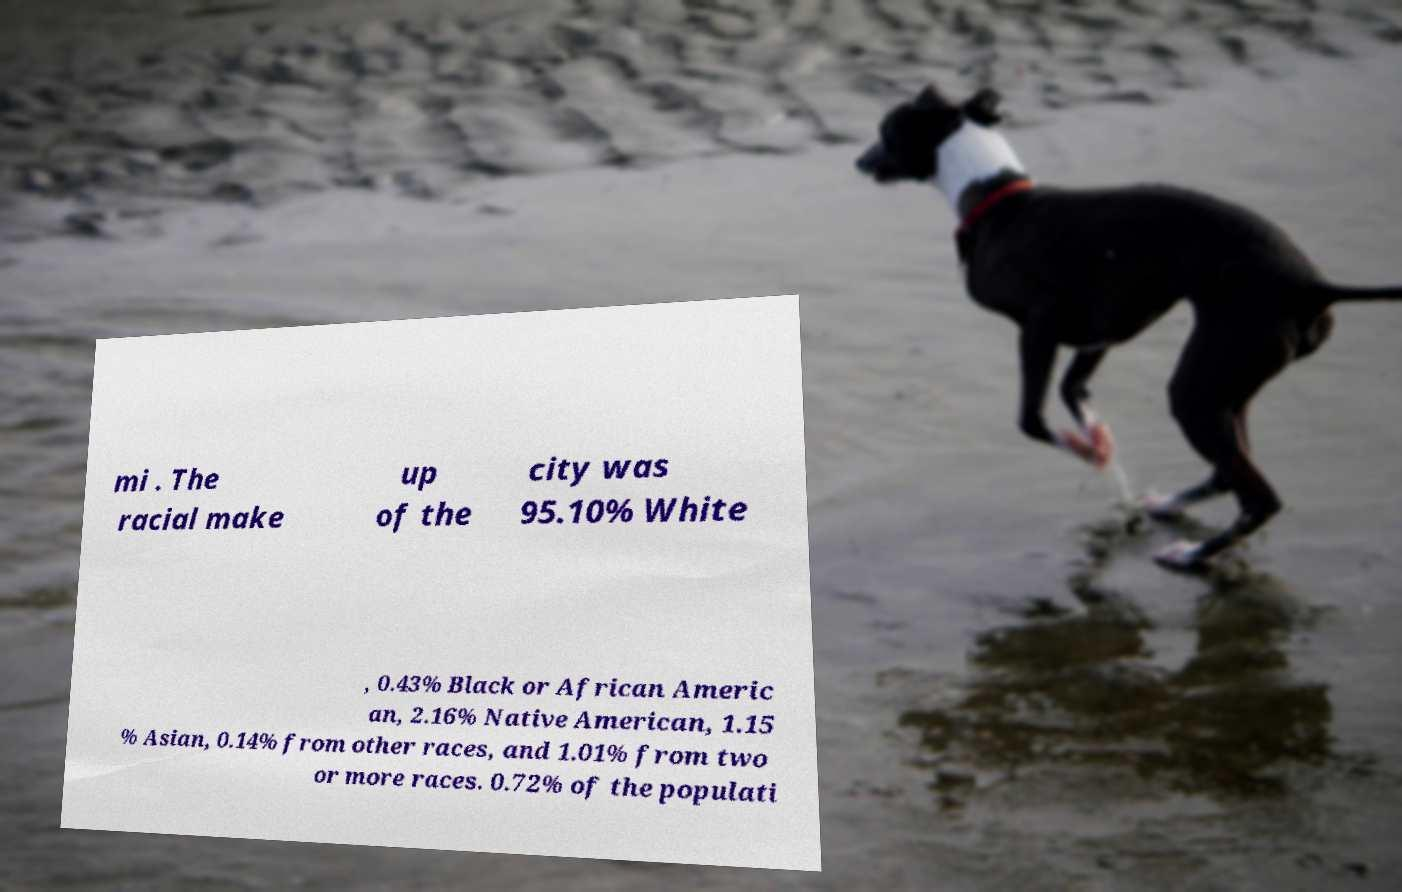Can you accurately transcribe the text from the provided image for me? mi . The racial make up of the city was 95.10% White , 0.43% Black or African Americ an, 2.16% Native American, 1.15 % Asian, 0.14% from other races, and 1.01% from two or more races. 0.72% of the populati 